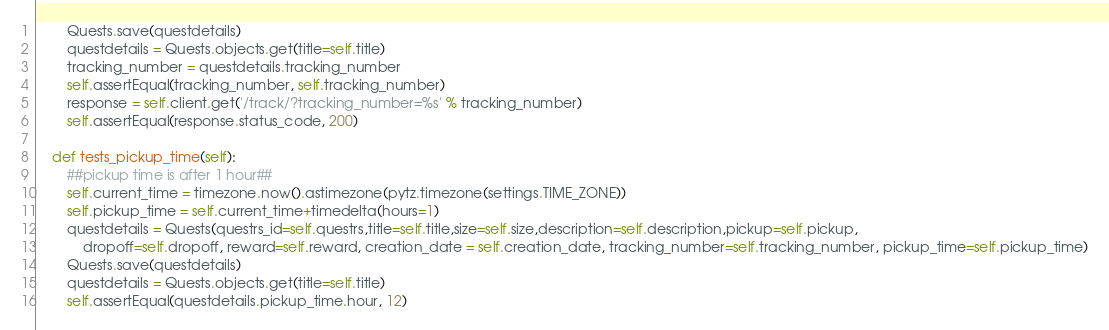Convert code to text. <code><loc_0><loc_0><loc_500><loc_500><_Python_>        Quests.save(questdetails)
        questdetails = Quests.objects.get(title=self.title)
        tracking_number = questdetails.tracking_number
        self.assertEqual(tracking_number, self.tracking_number)
        response = self.client.get('/track/?tracking_number=%s' % tracking_number)
        self.assertEqual(response.status_code, 200)

    def tests_pickup_time(self):
        ##pickup time is after 1 hour##
        self.current_time = timezone.now().astimezone(pytz.timezone(settings.TIME_ZONE))
        self.pickup_time = self.current_time+timedelta(hours=1)
        questdetails = Quests(questrs_id=self.questrs,title=self.title,size=self.size,description=self.description,pickup=self.pickup,
            dropoff=self.dropoff, reward=self.reward, creation_date = self.creation_date, tracking_number=self.tracking_number, pickup_time=self.pickup_time)
        Quests.save(questdetails)
        questdetails = Quests.objects.get(title=self.title)
        self.assertEqual(questdetails.pickup_time.hour, 12)
</code> 